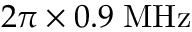Convert formula to latex. <formula><loc_0><loc_0><loc_500><loc_500>2 \pi \times 0 . 9 \, M H z</formula> 